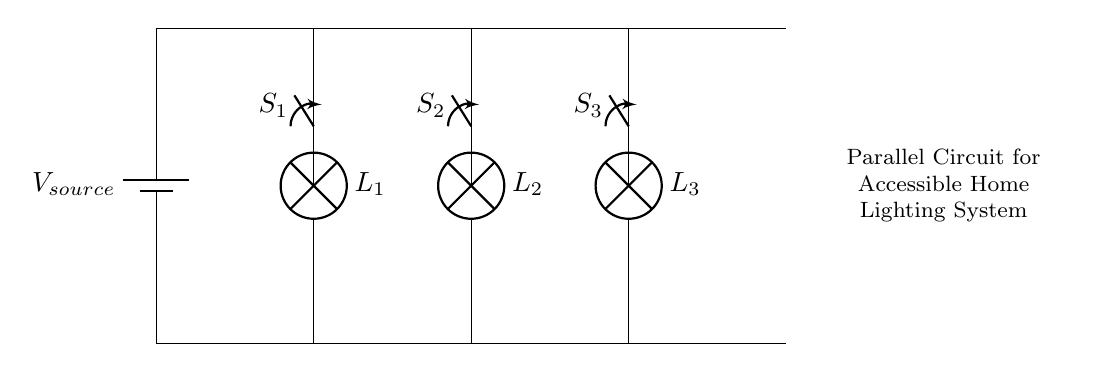What is the total number of lamps in this circuit? There are three lamps (L1, L2, and L3) shown in the diagram, which are the lighting components intended for the parallel circuit connection.
Answer: 3 What type of circuit is represented here? The circuit diagram represents a parallel circuit, where lamps and switches are connected in parallel to the power source, allowing individual operation of each lamp.
Answer: Parallel What is the purpose of the switches in this circuit? The switches (S1, S2, S3) allow for the individual control of each lamp, enabling them to be turned on or off independently, which is beneficial in a lighting system designed for accessibility.
Answer: Individual control If one lamp fails, how do the others behave? In a parallel circuit, if one lamp fails, the others continue to function because each lamp has its own direct connection to the power source. This ensures that the overall circuit remains operational regardless of individual lamp failures.
Answer: Others remain operational What is the source of power in this circuit? The circuit diagram indicates a battery labeled as Vsource, which serves as the power supply for the entire lighting system.
Answer: Battery Which lamp corresponds to switch S2? Lamp L2 is connected to switch S2, allowing it to be controlled directly by this switch in the parallel circuit arrangement.
Answer: Lamp L2 